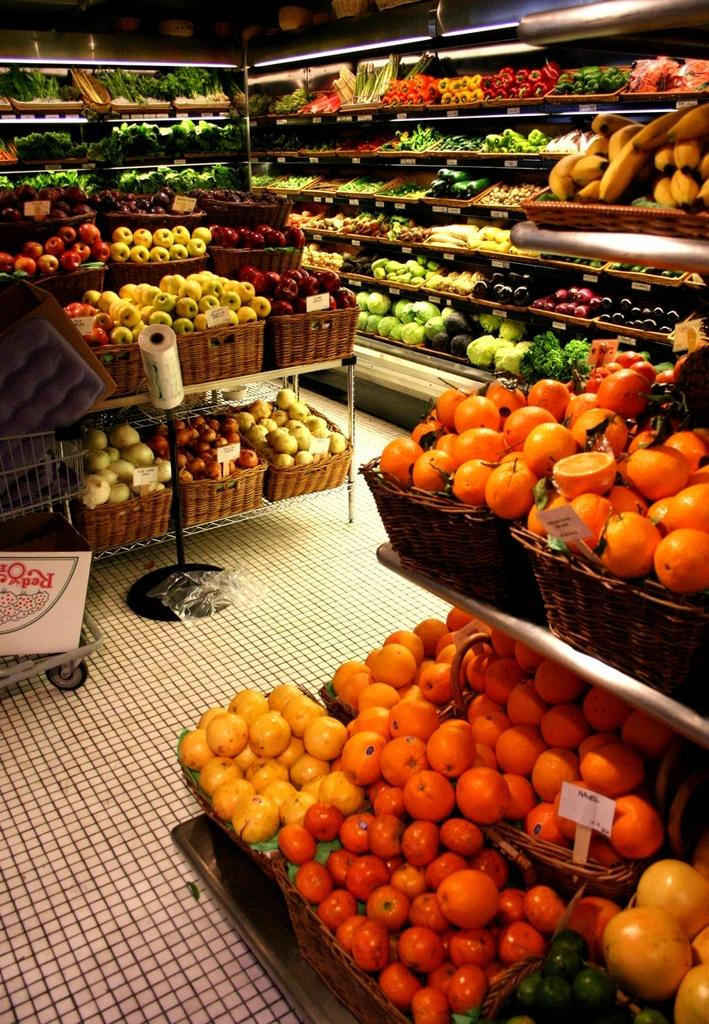What type of establishment is shown in the picture? There is a supermarket in the picture. What can be found on the racks inside the supermarket? The racks are filled with fruits and vegetables. What are the tables with baskets used for in the supermarket? The tables with baskets are likely used for customers to place their items while shopping. What type of class is being taught in the supermarket? There is no class being taught in the supermarket; the image only shows a supermarket with racks and tables. 